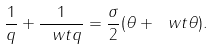<formula> <loc_0><loc_0><loc_500><loc_500>\frac { 1 } { q } + \frac { 1 } { \ w t { q } } = \frac { \sigma } { 2 } ( \theta + \ w t { \theta } ) .</formula> 